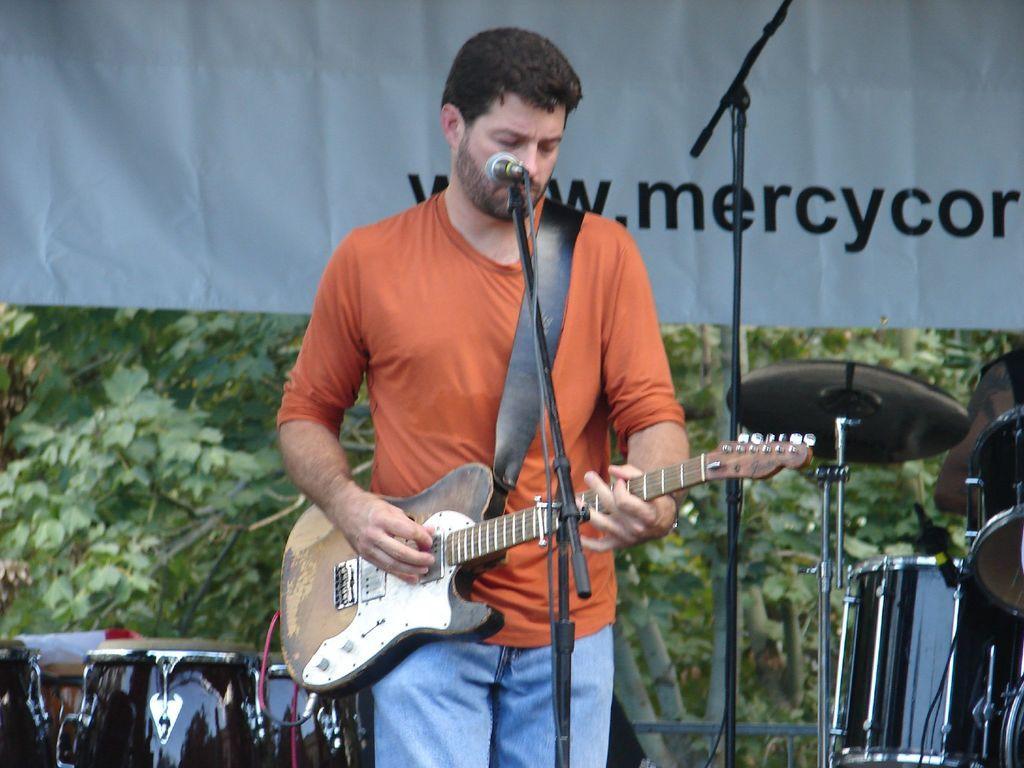How would you summarize this image in a sentence or two? In this image there is a man who is standing and playing the guitar with his hand. At the background there are drums,musical plate. In front of the man there is a mic. At the background there are trees and a banner. 